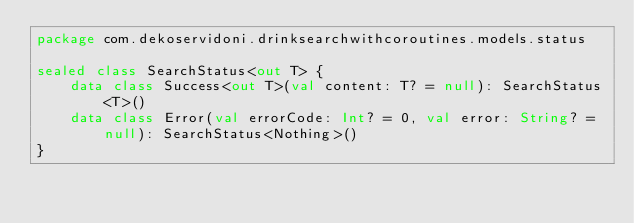Convert code to text. <code><loc_0><loc_0><loc_500><loc_500><_Kotlin_>package com.dekoservidoni.drinksearchwithcoroutines.models.status

sealed class SearchStatus<out T> {
    data class Success<out T>(val content: T? = null): SearchStatus<T>()
    data class Error(val errorCode: Int? = 0, val error: String? = null): SearchStatus<Nothing>()
}</code> 